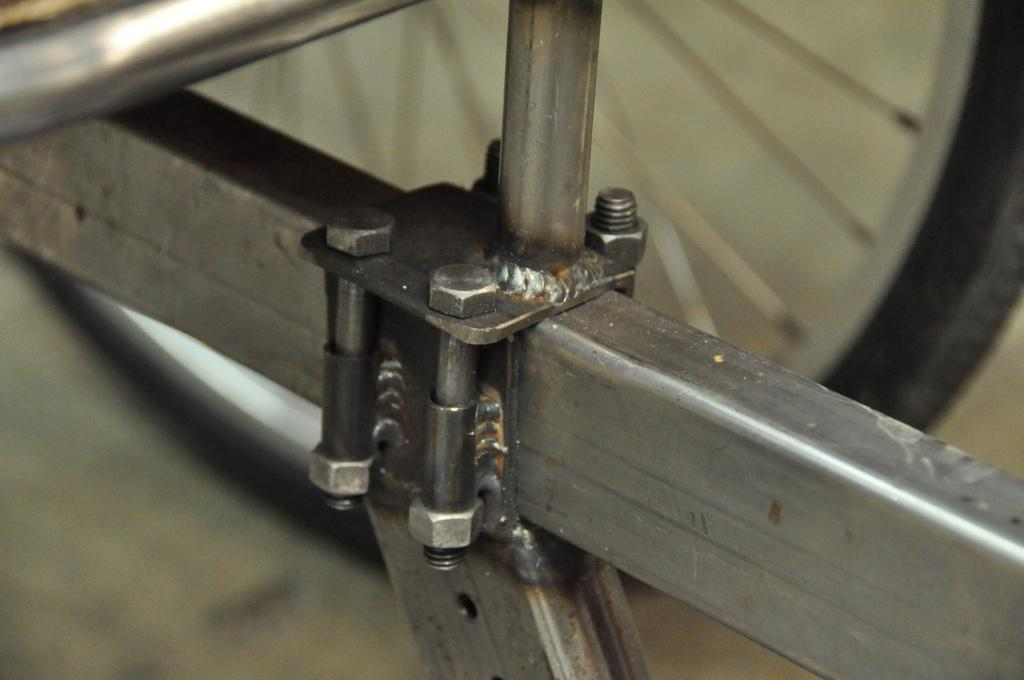What type of material is used for the rods in the image? The rods in the image are made of iron. What are the iron rods being used for? The iron rods have nuts and bolts on them, suggesting they are being used for construction or assembly. Can you describe any other objects visible in the image? There is a wheel visible in the background of the image. What is the price of the cattle in the image? There are no cattle present in the image, so it is not possible to determine their price. 